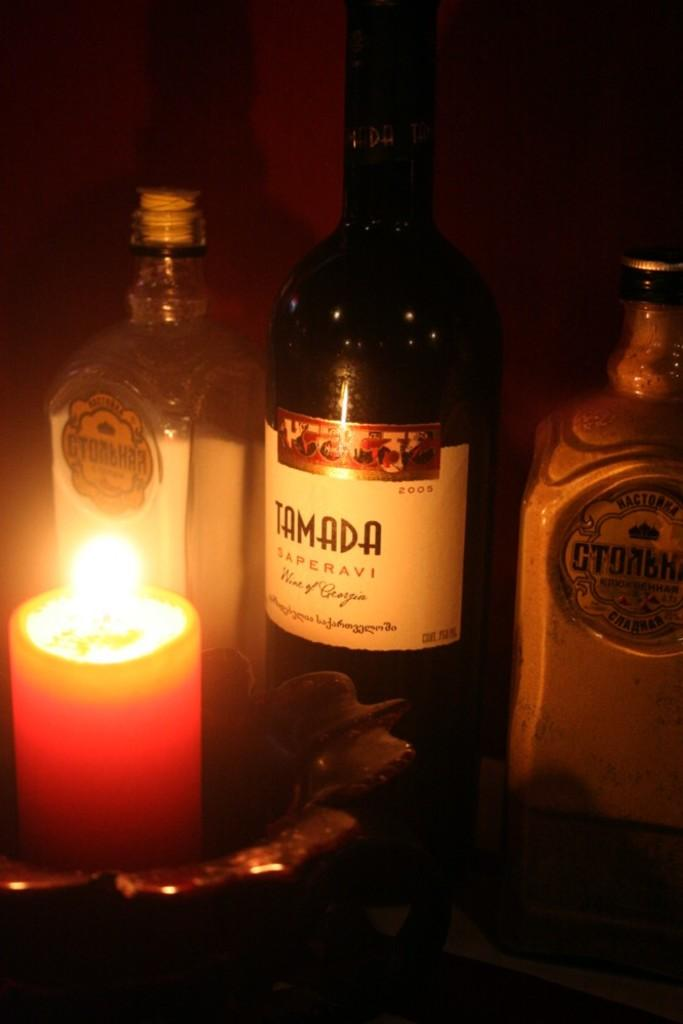<image>
Present a compact description of the photo's key features. A bottle of Tamada is on a table in front of a lit candle. 